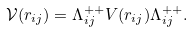Convert formula to latex. <formula><loc_0><loc_0><loc_500><loc_500>\mathcal { V } ( r _ { i j } ) = \Lambda _ { i j } ^ { + + } V ( r _ { i j } ) \Lambda _ { i j } ^ { + + } .</formula> 